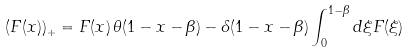<formula> <loc_0><loc_0><loc_500><loc_500>\left ( F ( x ) \right ) _ { + } = F ( x ) \, \theta ( 1 - x - \beta ) - \delta ( 1 - x - \beta ) \int _ { 0 } ^ { 1 - \beta } d \xi F ( \xi )</formula> 